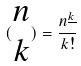<formula> <loc_0><loc_0><loc_500><loc_500>( \begin{matrix} n \\ k \end{matrix} ) = \frac { n ^ { \underline { k } } } { k ! }</formula> 